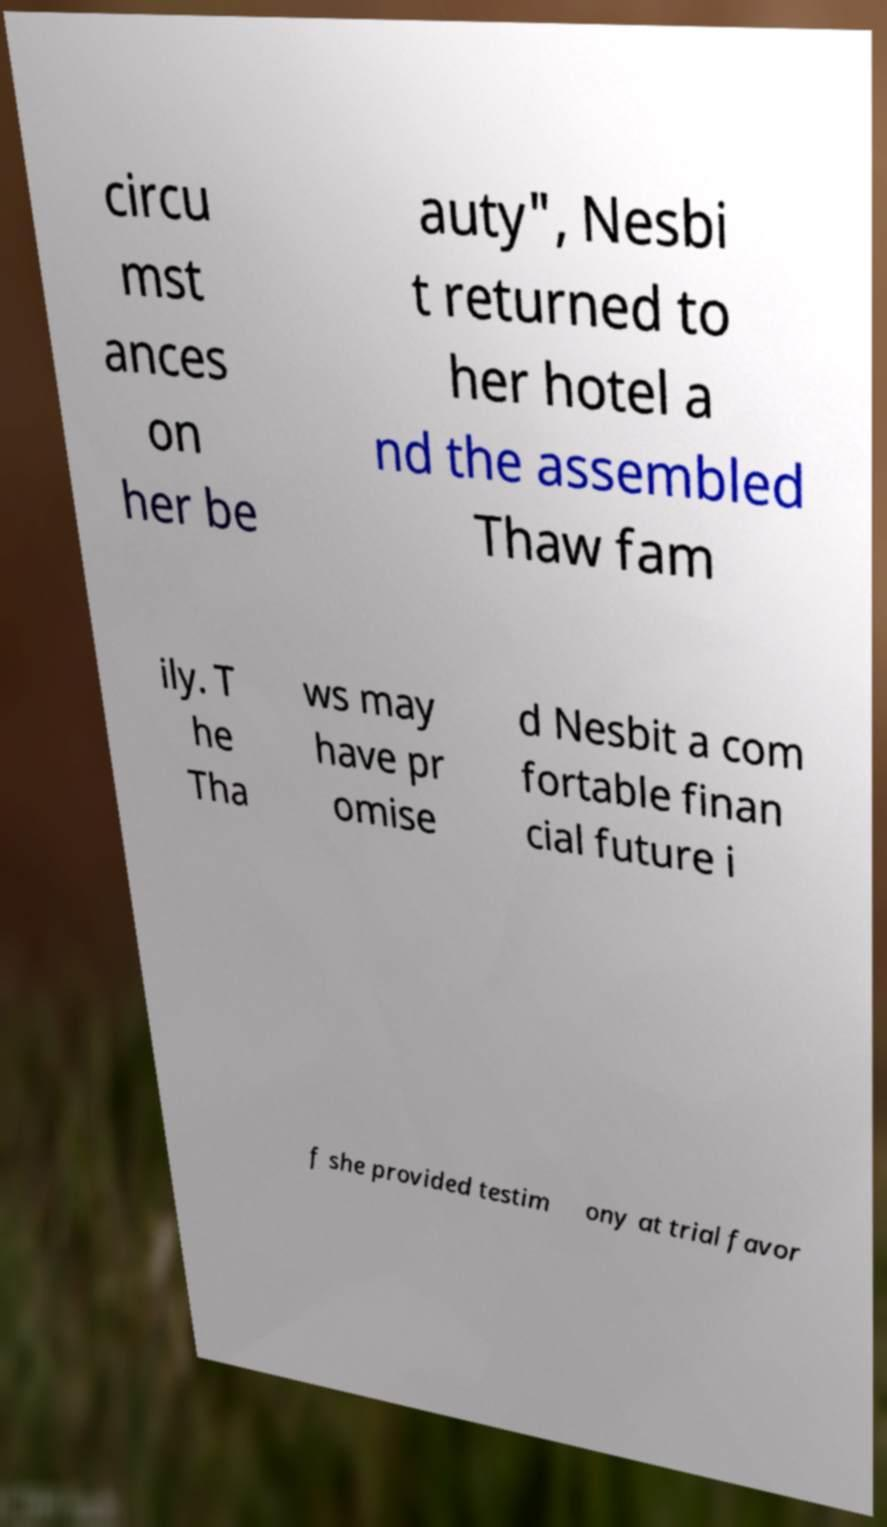For documentation purposes, I need the text within this image transcribed. Could you provide that? circu mst ances on her be auty", Nesbi t returned to her hotel a nd the assembled Thaw fam ily. T he Tha ws may have pr omise d Nesbit a com fortable finan cial future i f she provided testim ony at trial favor 